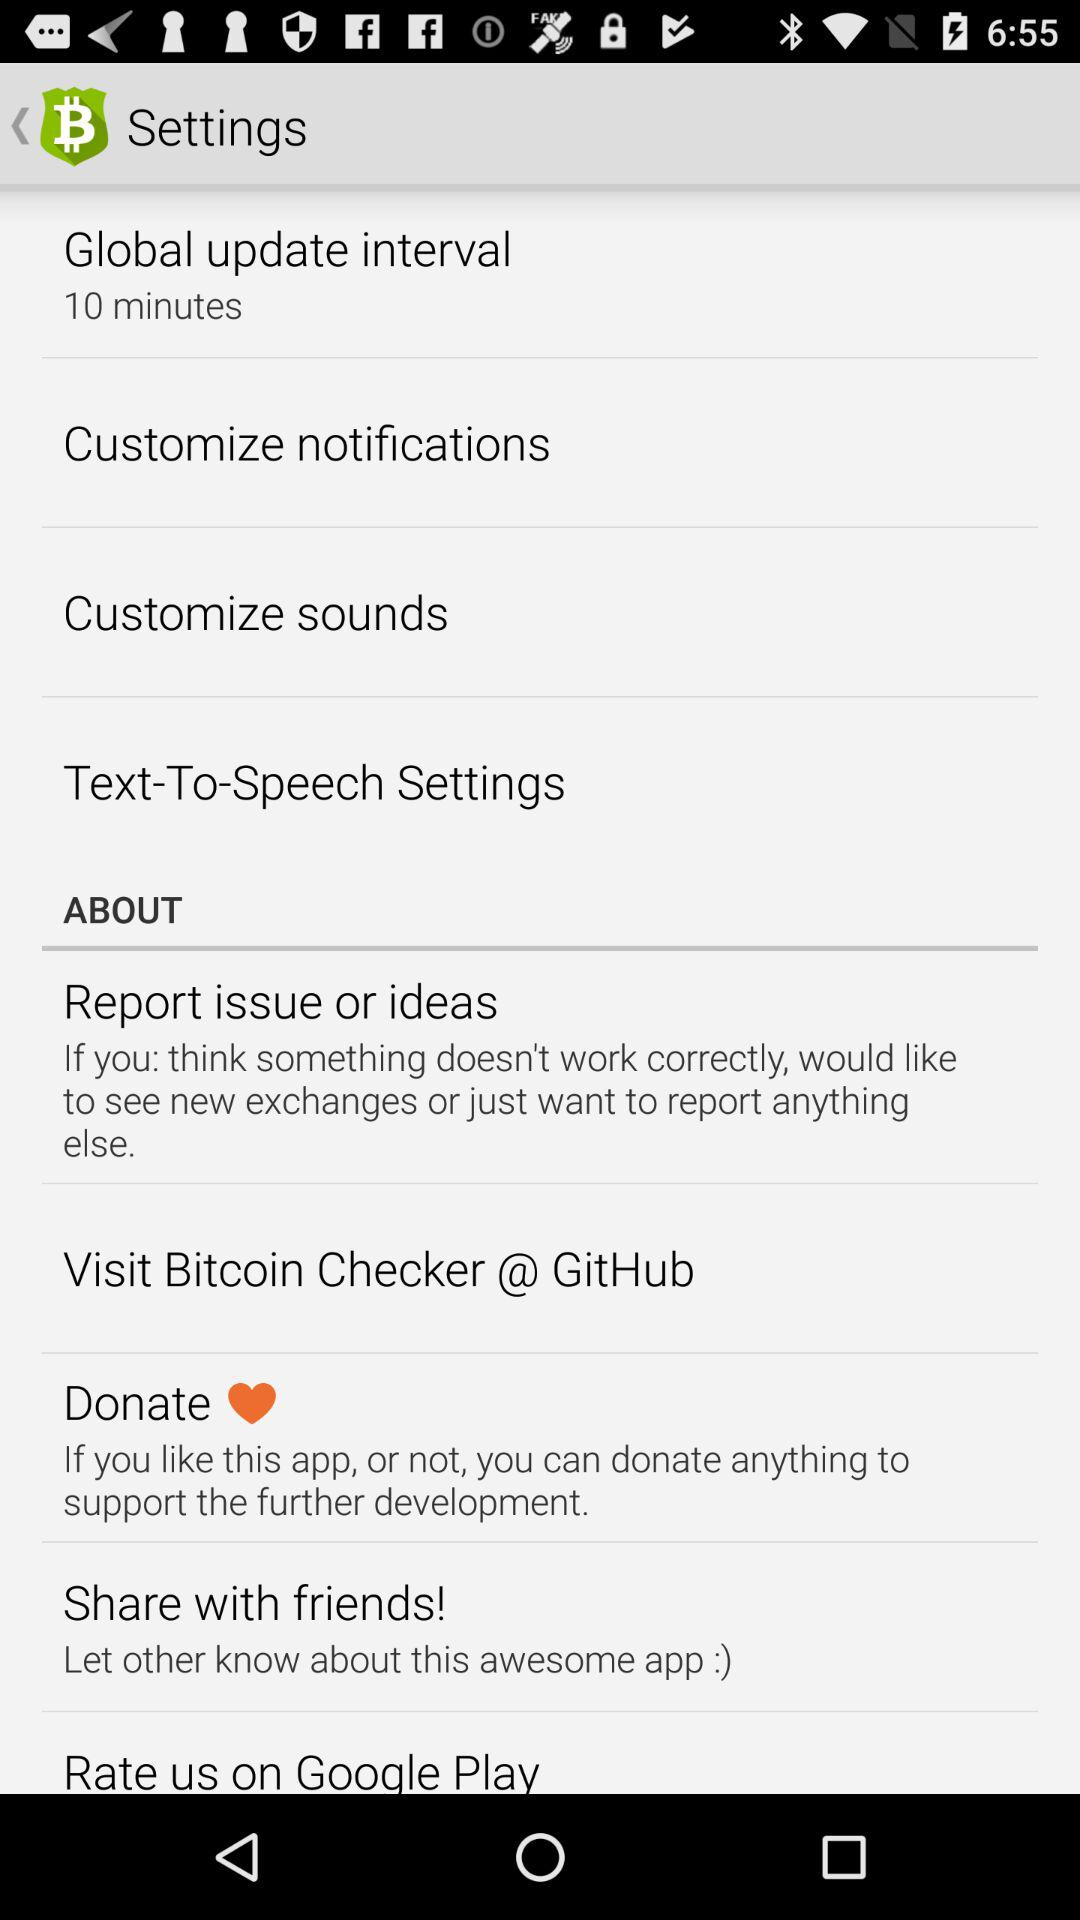What was the global update interval? The global update interval is 10 minutes. 